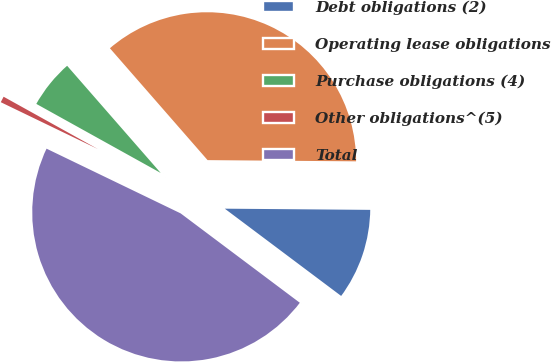<chart> <loc_0><loc_0><loc_500><loc_500><pie_chart><fcel>Debt obligations (2)<fcel>Operating lease obligations<fcel>Purchase obligations (4)<fcel>Other obligations^(5)<fcel>Total<nl><fcel>10.11%<fcel>36.55%<fcel>5.51%<fcel>0.91%<fcel>46.91%<nl></chart> 